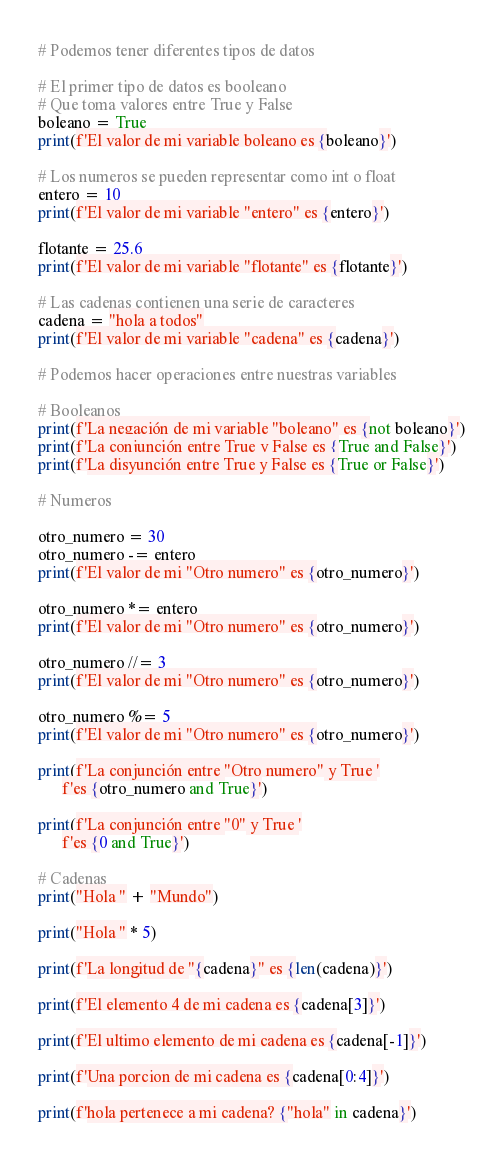Convert code to text. <code><loc_0><loc_0><loc_500><loc_500><_Python_># Podemos tener diferentes tipos de datos

# El primer tipo de datos es booleano
# Que toma valores entre True y False
boleano = True
print(f'El valor de mi variable boleano es {boleano}')

# Los numeros se pueden representar como int o float
entero = 10
print(f'El valor de mi variable "entero" es {entero}')

flotante = 25.6
print(f'El valor de mi variable "flotante" es {flotante}')

# Las cadenas contienen una serie de caracteres
cadena = "hola a todos"
print(f'El valor de mi variable "cadena" es {cadena}')

# Podemos hacer operaciones entre nuestras variables

# Booleanos
print(f'La negación de mi variable "boleano" es {not boleano}')
print(f'La conjunción entre True y False es {True and False}')
print(f'La disyunción entre True y False es {True or False}')

# Numeros

otro_numero = 30
otro_numero -= entero
print(f'El valor de mi "Otro numero" es {otro_numero}')

otro_numero *= entero
print(f'El valor de mi "Otro numero" es {otro_numero}')

otro_numero //= 3
print(f'El valor de mi "Otro numero" es {otro_numero}')

otro_numero %= 5
print(f'El valor de mi "Otro numero" es {otro_numero}')

print(f'La conjunción entre "Otro numero" y True '
      f'es {otro_numero and True}')

print(f'La conjunción entre "0" y True '
      f'es {0 and True}')

# Cadenas
print("Hola " + "Mundo")

print("Hola " * 5)

print(f'La longitud de "{cadena}" es {len(cadena)}')

print(f'El elemento 4 de mi cadena es {cadena[3]}')

print(f'El ultimo elemento de mi cadena es {cadena[-1]}')

print(f'Una porcion de mi cadena es {cadena[0:4]}')

print(f'hola pertenece a mi cadena? {"hola" in cadena}')




</code> 